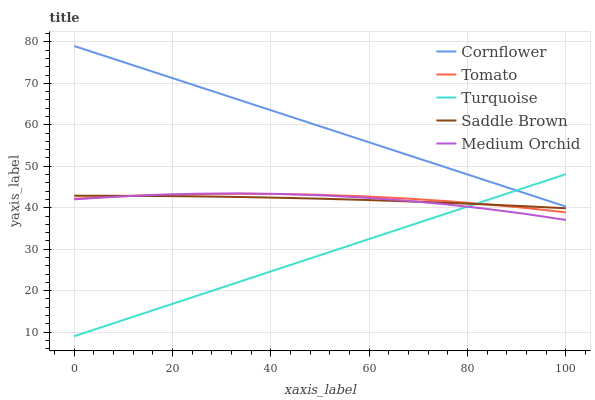Does Turquoise have the minimum area under the curve?
Answer yes or no. Yes. Does Cornflower have the maximum area under the curve?
Answer yes or no. Yes. Does Cornflower have the minimum area under the curve?
Answer yes or no. No. Does Turquoise have the maximum area under the curve?
Answer yes or no. No. Is Turquoise the smoothest?
Answer yes or no. Yes. Is Medium Orchid the roughest?
Answer yes or no. Yes. Is Cornflower the smoothest?
Answer yes or no. No. Is Cornflower the roughest?
Answer yes or no. No. Does Turquoise have the lowest value?
Answer yes or no. Yes. Does Cornflower have the lowest value?
Answer yes or no. No. Does Cornflower have the highest value?
Answer yes or no. Yes. Does Turquoise have the highest value?
Answer yes or no. No. Is Tomato less than Cornflower?
Answer yes or no. Yes. Is Cornflower greater than Saddle Brown?
Answer yes or no. Yes. Does Tomato intersect Saddle Brown?
Answer yes or no. Yes. Is Tomato less than Saddle Brown?
Answer yes or no. No. Is Tomato greater than Saddle Brown?
Answer yes or no. No. Does Tomato intersect Cornflower?
Answer yes or no. No. 